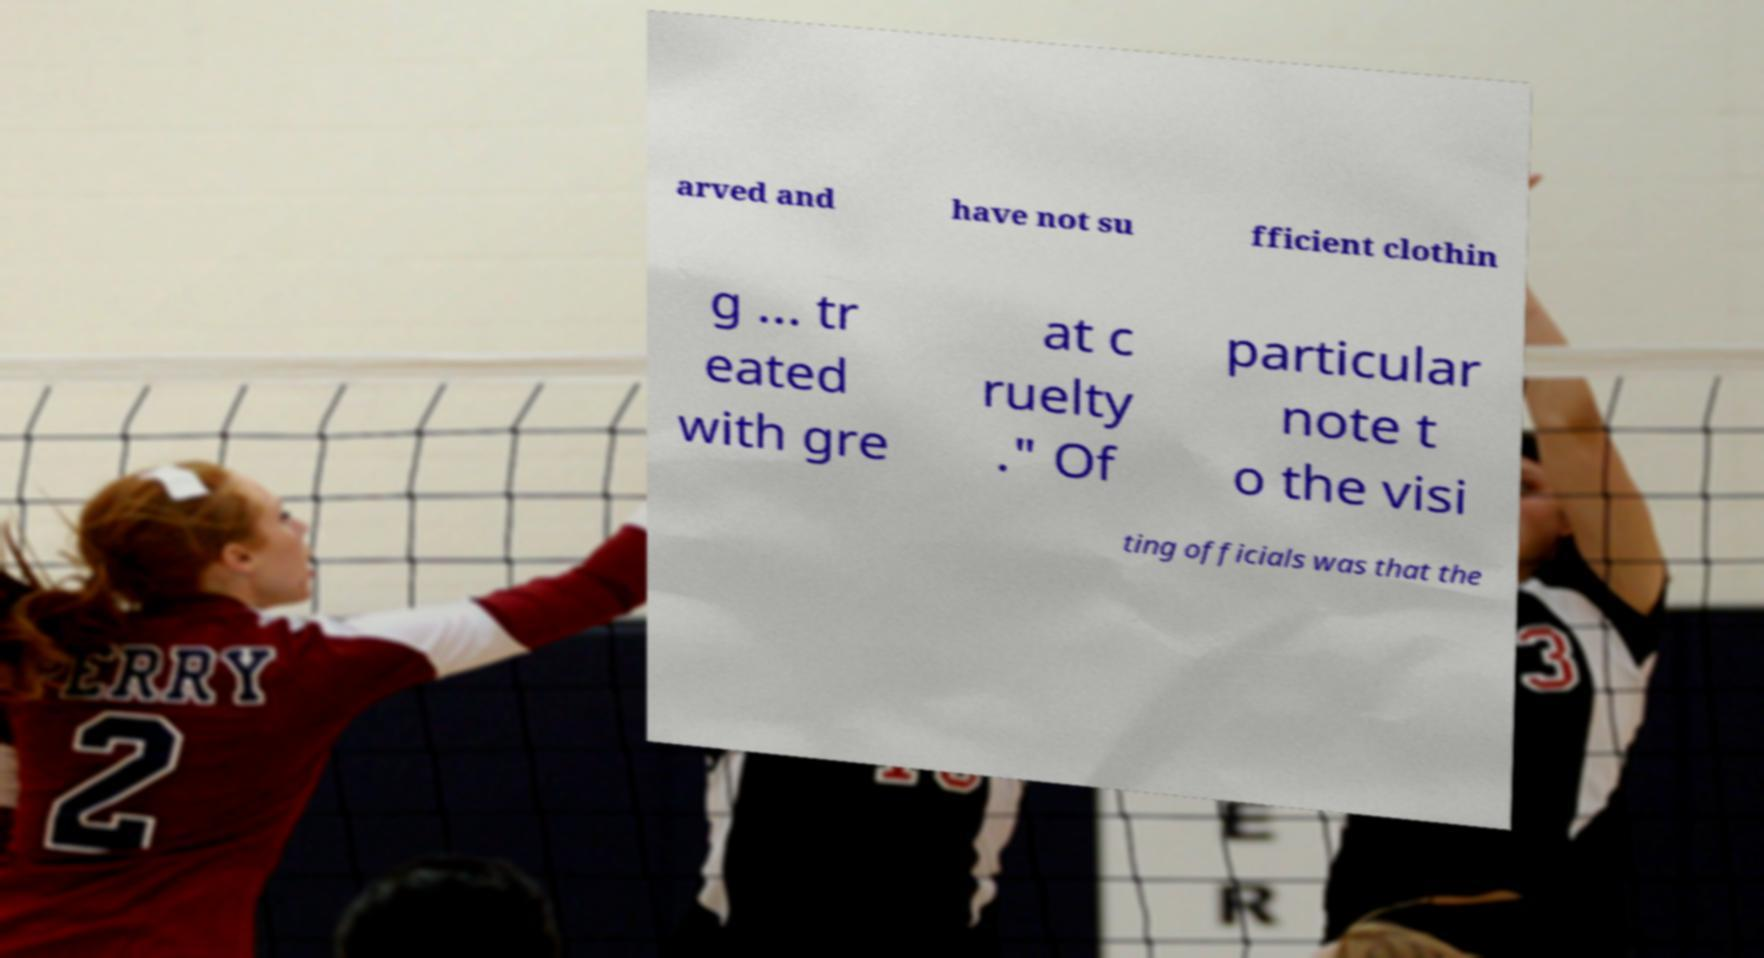Can you read and provide the text displayed in the image?This photo seems to have some interesting text. Can you extract and type it out for me? arved and have not su fficient clothin g ... tr eated with gre at c ruelty ." Of particular note t o the visi ting officials was that the 